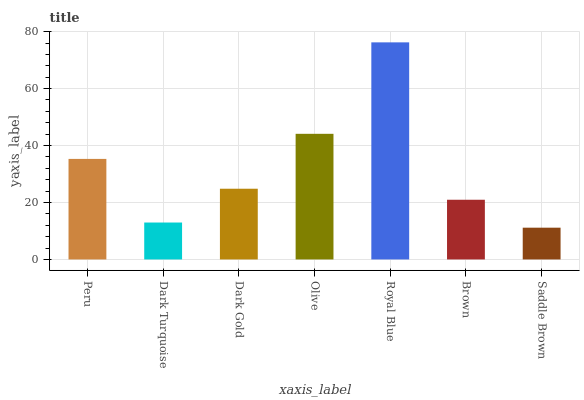Is Dark Turquoise the minimum?
Answer yes or no. No. Is Dark Turquoise the maximum?
Answer yes or no. No. Is Peru greater than Dark Turquoise?
Answer yes or no. Yes. Is Dark Turquoise less than Peru?
Answer yes or no. Yes. Is Dark Turquoise greater than Peru?
Answer yes or no. No. Is Peru less than Dark Turquoise?
Answer yes or no. No. Is Dark Gold the high median?
Answer yes or no. Yes. Is Dark Gold the low median?
Answer yes or no. Yes. Is Brown the high median?
Answer yes or no. No. Is Olive the low median?
Answer yes or no. No. 